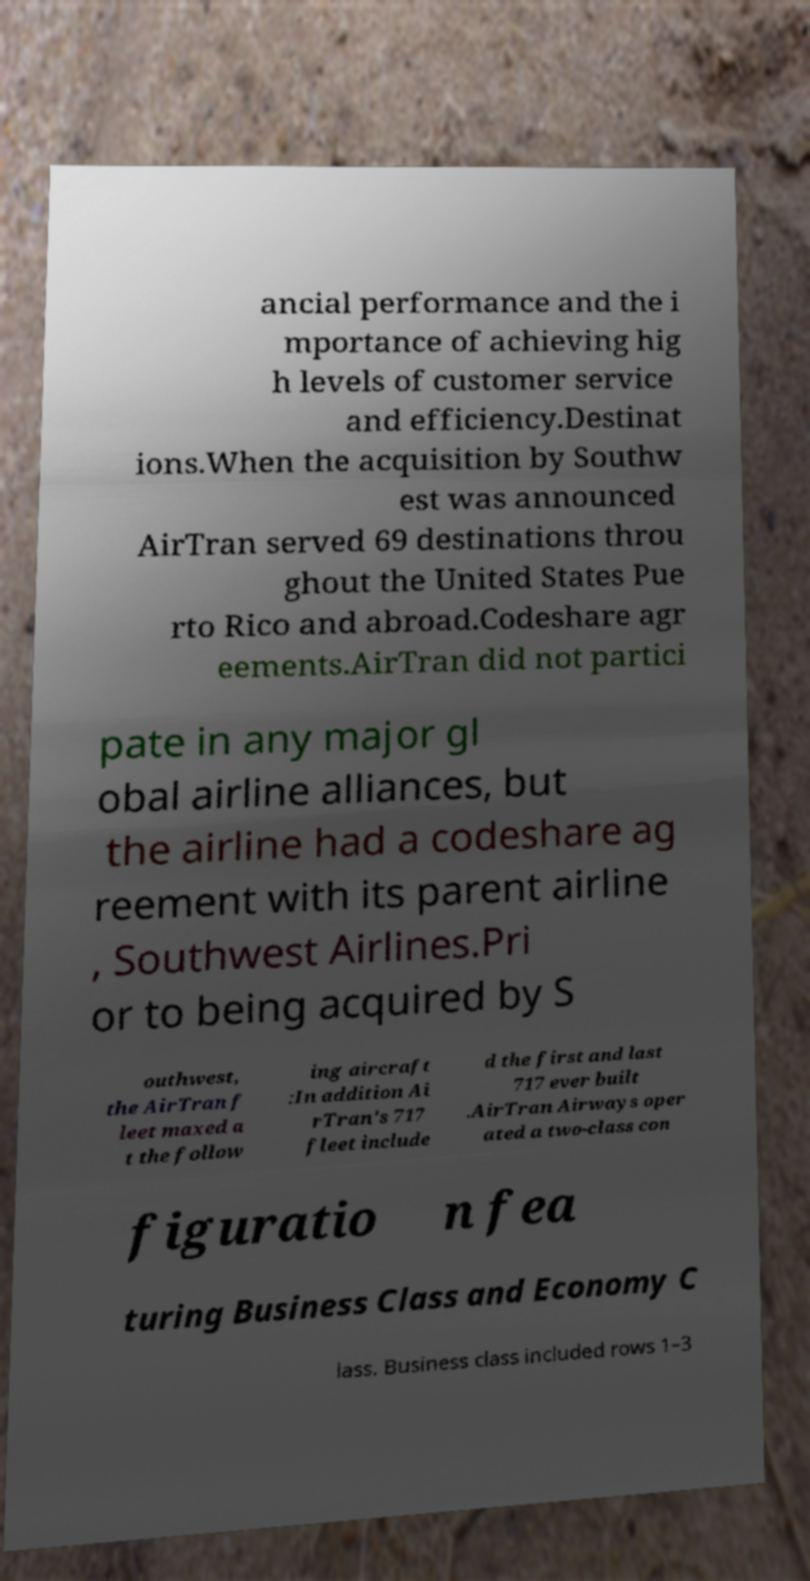Could you extract and type out the text from this image? ancial performance and the i mportance of achieving hig h levels of customer service and efficiency.Destinat ions.When the acquisition by Southw est was announced AirTran served 69 destinations throu ghout the United States Pue rto Rico and abroad.Codeshare agr eements.AirTran did not partici pate in any major gl obal airline alliances, but the airline had a codeshare ag reement with its parent airline , Southwest Airlines.Pri or to being acquired by S outhwest, the AirTran f leet maxed a t the follow ing aircraft :In addition Ai rTran's 717 fleet include d the first and last 717 ever built .AirTran Airways oper ated a two-class con figuratio n fea turing Business Class and Economy C lass. Business class included rows 1–3 